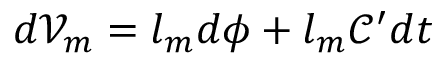Convert formula to latex. <formula><loc_0><loc_0><loc_500><loc_500>d \mathcal { V } _ { m } = l _ { m } d \phi + l _ { m } \mathcal { C } ^ { \prime } d t</formula> 